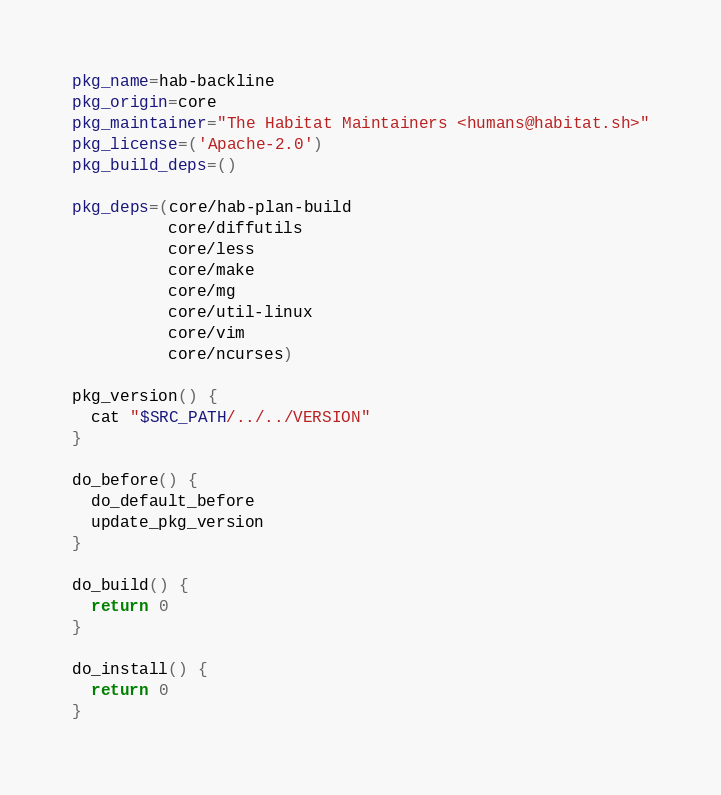Convert code to text. <code><loc_0><loc_0><loc_500><loc_500><_Bash_>pkg_name=hab-backline
pkg_origin=core
pkg_maintainer="The Habitat Maintainers <humans@habitat.sh>"
pkg_license=('Apache-2.0')
pkg_build_deps=()

pkg_deps=(core/hab-plan-build
          core/diffutils
          core/less
          core/make
          core/mg
          core/util-linux
          core/vim
          core/ncurses)

pkg_version() {
  cat "$SRC_PATH/../../VERSION"
}

do_before() {
  do_default_before
  update_pkg_version
}

do_build() {
  return 0
}

do_install() {
  return 0
}
</code> 